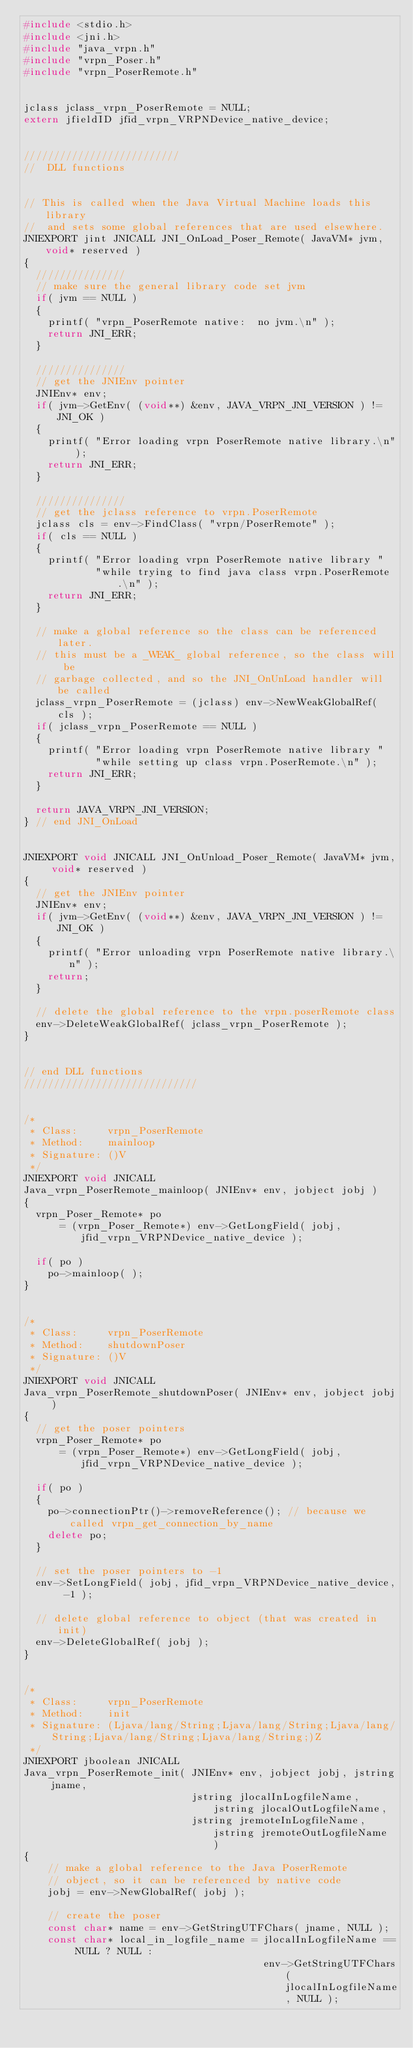<code> <loc_0><loc_0><loc_500><loc_500><_C++_>#include <stdio.h>
#include <jni.h>
#include "java_vrpn.h"
#include "vrpn_Poser.h"
#include "vrpn_PoserRemote.h"


jclass jclass_vrpn_PoserRemote = NULL;
extern jfieldID jfid_vrpn_VRPNDevice_native_device;


//////////////////////////
//  DLL functions


// This is called when the Java Virtual Machine loads this library
//  and sets some global references that are used elsewhere.
JNIEXPORT jint JNICALL JNI_OnLoad_Poser_Remote( JavaVM* jvm, void* reserved )
{
  ///////////////
  // make sure the general library code set jvm
  if( jvm == NULL )
  {
	printf( "vrpn_PoserRemote native:  no jvm.\n" );
    return JNI_ERR;
  }

  ///////////////
  // get the JNIEnv pointer
  JNIEnv* env;
  if( jvm->GetEnv( (void**) &env, JAVA_VRPN_JNI_VERSION ) != JNI_OK )
  {
    printf( "Error loading vrpn PoserRemote native library.\n" );
    return JNI_ERR;
  }
  
  ///////////////
  // get the jclass reference to vrpn.PoserRemote
  jclass cls = env->FindClass( "vrpn/PoserRemote" );
  if( cls == NULL )
  {
    printf( "Error loading vrpn PoserRemote native library "
            "while trying to find java class vrpn.PoserRemote.\n" );
    return JNI_ERR;
  }

  // make a global reference so the class can be referenced later.
  // this must be a _WEAK_ global reference, so the class will be
  // garbage collected, and so the JNI_OnUnLoad handler will be called
  jclass_vrpn_PoserRemote = (jclass) env->NewWeakGlobalRef( cls );
  if( jclass_vrpn_PoserRemote == NULL )
  {
    printf( "Error loading vrpn PoserRemote native library "
            "while setting up class vrpn.PoserRemote.\n" );
    return JNI_ERR;
  }

  return JAVA_VRPN_JNI_VERSION;
} // end JNI_OnLoad


JNIEXPORT void JNICALL JNI_OnUnload_Poser_Remote( JavaVM* jvm, void* reserved )
{
  // get the JNIEnv pointer
  JNIEnv* env;
  if( jvm->GetEnv( (void**) &env, JAVA_VRPN_JNI_VERSION ) != JNI_OK )
  {
    printf( "Error unloading vrpn PoserRemote native library.\n" );
    return;
  }

  // delete the global reference to the vrpn.poserRemote class
  env->DeleteWeakGlobalRef( jclass_vrpn_PoserRemote );
}


// end DLL functions
/////////////////////////////


/*
 * Class:     vrpn_PoserRemote
 * Method:    mainloop
 * Signature: ()V
 */
JNIEXPORT void JNICALL 
Java_vrpn_PoserRemote_mainloop( JNIEnv* env, jobject jobj )
{
  vrpn_Poser_Remote* po 
	  = (vrpn_Poser_Remote*) env->GetLongField( jobj, jfid_vrpn_VRPNDevice_native_device );

  if( po )
	po->mainloop( );
}


/*
 * Class:     vrpn_PoserRemote
 * Method:    shutdownPoser
 * Signature: ()V
 */
JNIEXPORT void JNICALL 
Java_vrpn_PoserRemote_shutdownPoser( JNIEnv* env, jobject jobj )
{
  // get the poser pointers
  vrpn_Poser_Remote* po 
	  = (vrpn_Poser_Remote*) env->GetLongField( jobj, jfid_vrpn_VRPNDevice_native_device );

  if( po )
  {
	po->connectionPtr()->removeReference(); // because we called vrpn_get_connection_by_name
	delete po;
  }
   
  // set the poser pointers to -1
  env->SetLongField( jobj, jfid_vrpn_VRPNDevice_native_device, -1 );

  // delete global reference to object (that was created in init)
  env->DeleteGlobalRef( jobj );
}


/*
 * Class:     vrpn_PoserRemote
 * Method:    init
 * Signature: (Ljava/lang/String;Ljava/lang/String;Ljava/lang/String;Ljava/lang/String;Ljava/lang/String;)Z
 */
JNIEXPORT jboolean JNICALL 
Java_vrpn_PoserRemote_init( JNIEnv* env, jobject jobj, jstring jname, 
						    jstring jlocalInLogfileName, jstring jlocalOutLogfileName,
							jstring jremoteInLogfileName, jstring jremoteOutLogfileName )
{
	// make a global reference to the Java PoserRemote
	// object, so it can be referenced by native code
	jobj = env->NewGlobalRef( jobj );
	
	// create the poser
	const char* name = env->GetStringUTFChars( jname, NULL );
	const char* local_in_logfile_name = jlocalInLogfileName == NULL ? NULL :
										env->GetStringUTFChars( jlocalInLogfileName, NULL );</code> 